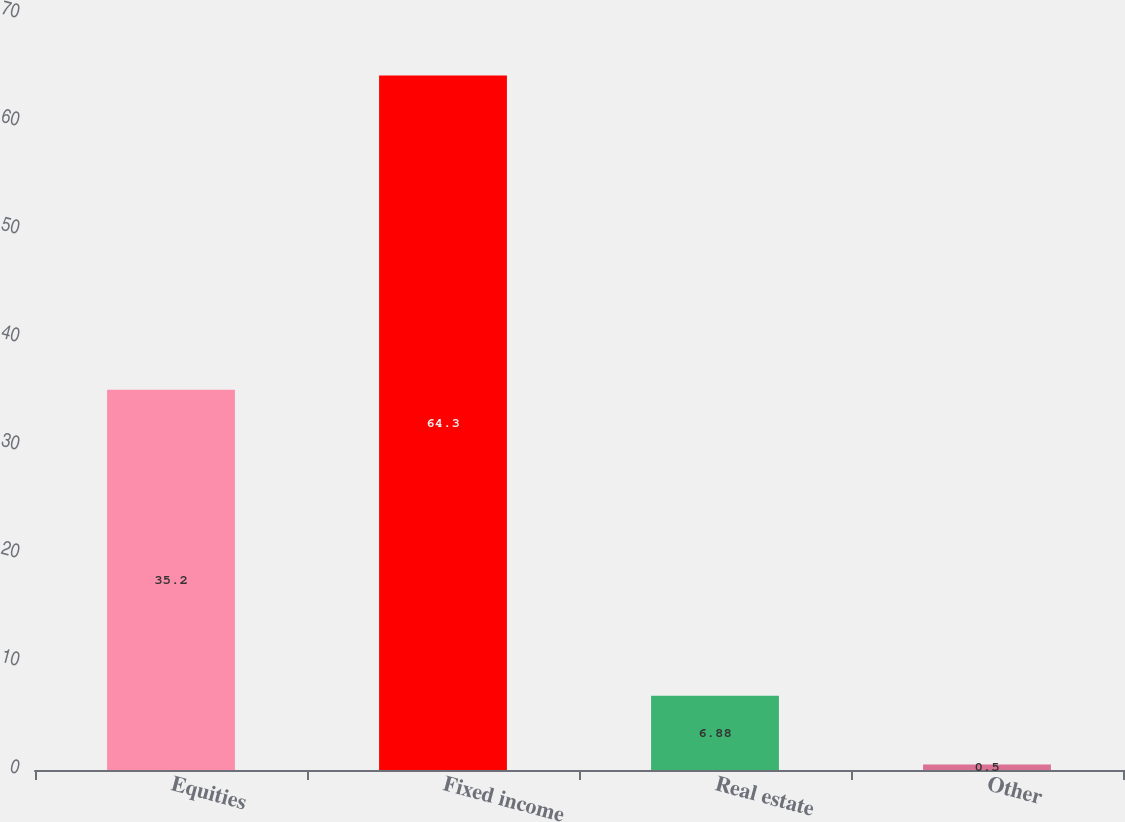Convert chart to OTSL. <chart><loc_0><loc_0><loc_500><loc_500><bar_chart><fcel>Equities<fcel>Fixed income<fcel>Real estate<fcel>Other<nl><fcel>35.2<fcel>64.3<fcel>6.88<fcel>0.5<nl></chart> 